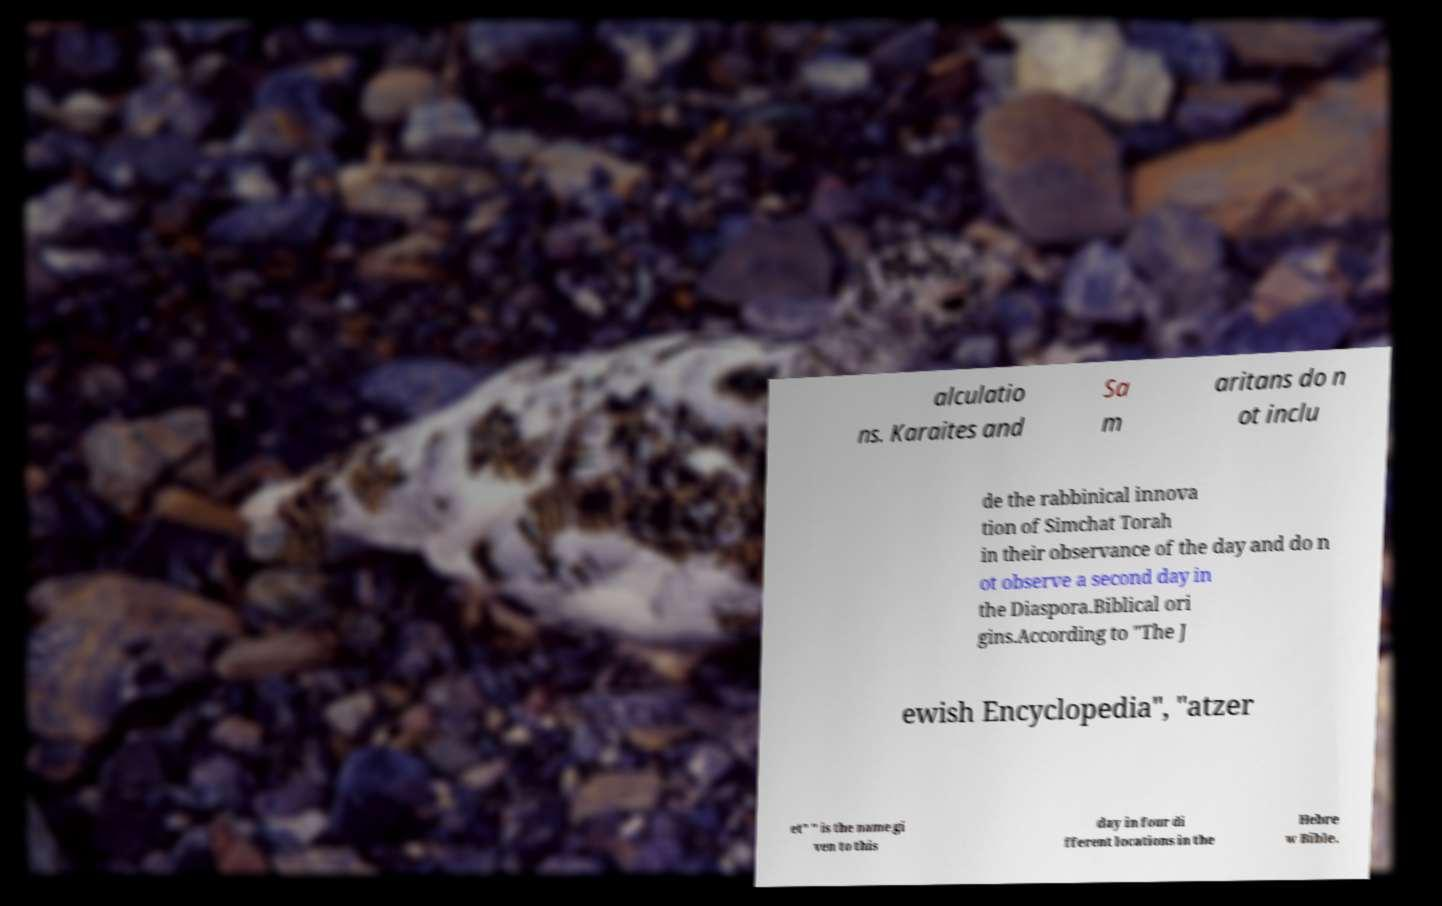I need the written content from this picture converted into text. Can you do that? alculatio ns. Karaites and Sa m aritans do n ot inclu de the rabbinical innova tion of Simchat Torah in their observance of the day and do n ot observe a second day in the Diaspora.Biblical ori gins.According to "The J ewish Encyclopedia", "atzer et" " is the name gi ven to this day in four di fferent locations in the Hebre w Bible. 